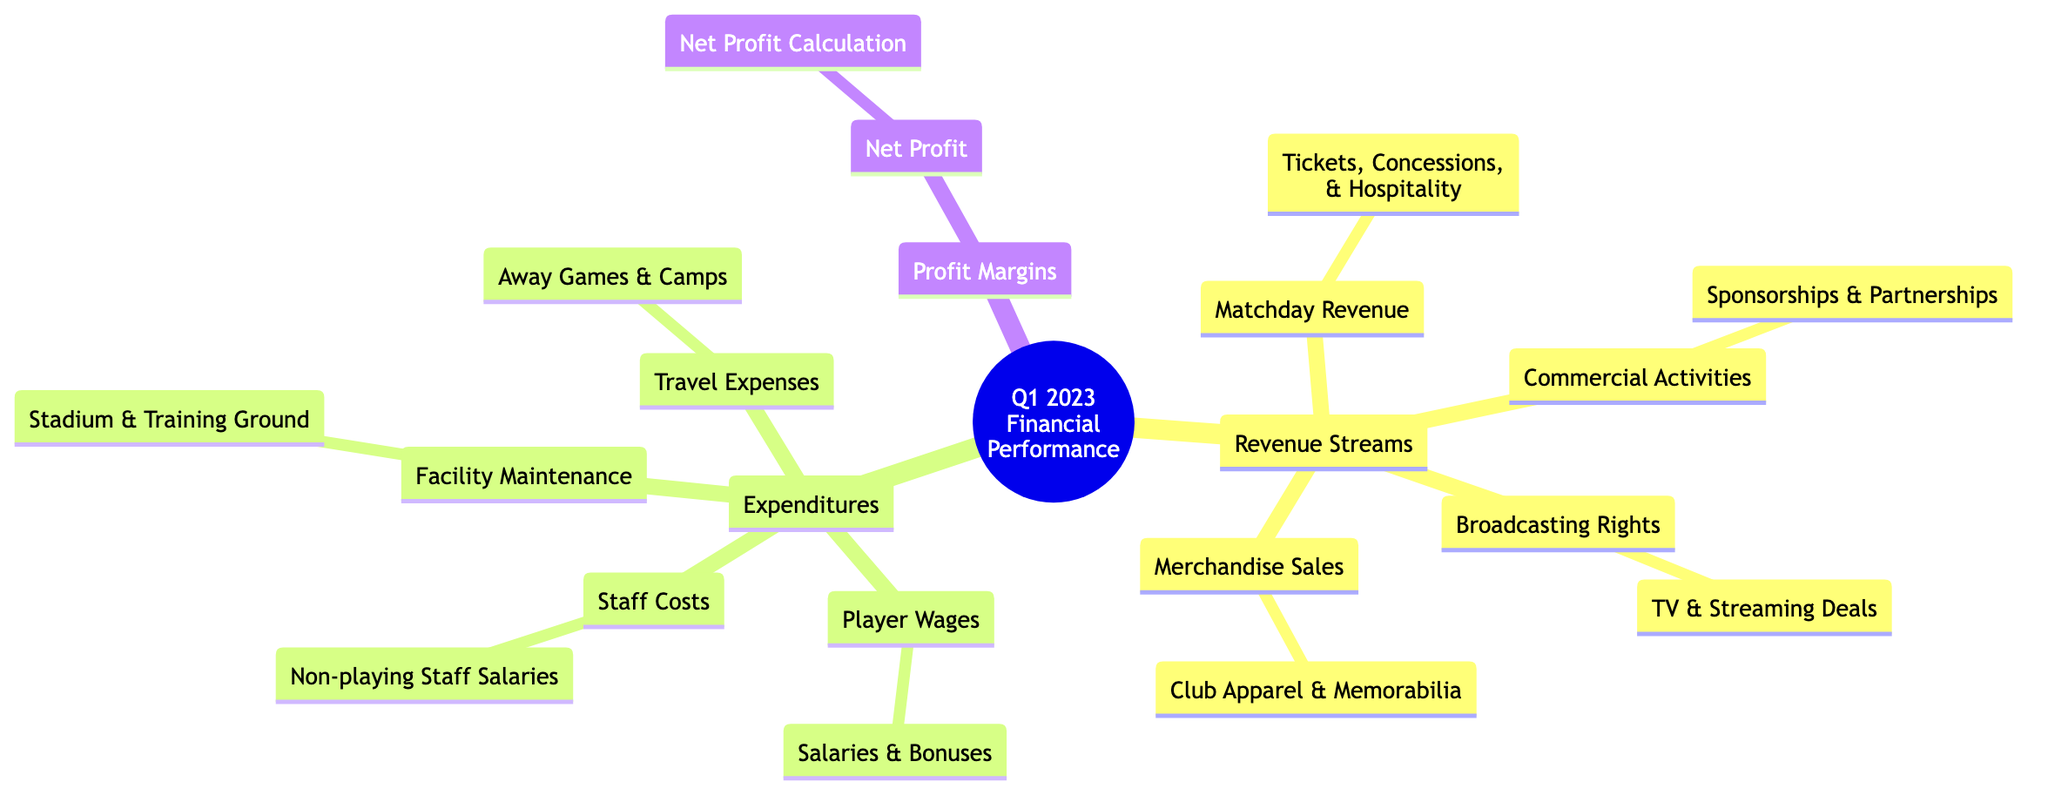What are the components of Revenue Streams? The diagram lists four components under Revenue Streams: Matchday Revenue, Broadcasting Rights, Commercial Activities, and Merchandise Sales. These are explicitly laid out under the Revenue Streams section of the diagram.
Answer: Matchday Revenue, Broadcasting Rights, Commercial Activities, Merchandise Sales Which expenditure is related to player salaries? Player Wages refer to the costs associated with salaries and bonuses paid to players, specified in the Expenditures section under Player Wages.
Answer: Player Wages How many main categories are there in Expenditures? The Expenditures section contains four main categories: Player Wages, Staff Costs, Facility Maintenance, and Travel Expenses. To find the number, we simply count the listed categories.
Answer: Four What is the relationship between Profit Margins and Net Profit? The diagram indicates that Net Profit is a type of calculation specifically related to Profit Margins, implying that Net Profit is part of the Profit Margins section.
Answer: Net Profit Which revenue stream includes sponsorships? Under the section for Revenue Streams, Sponsorships & Partnerships fall under Commercial Activities, indicating their relationship. Therefore, Commercial Activities are the revenue streams that include sponsorships.
Answer: Commercial Activities What are the non-revenue related expenditures listed? The non-revenue related expenditures include Staff Costs, Facility Maintenance, and Travel Expenses listed under Expenditures, as they do not generate revenue.
Answer: Staff Costs, Facility Maintenance, Travel Expenses Which category has the highest detail under Revenue Streams? The Matchday Revenue category contains the most detailed breakdown, specifying Tickets, Concessions, and Hospitality, which are subcomponents of Matchday Revenue.
Answer: Tickets, Concessions, Hospitality Are TV deals part of Broadcasting Rights? Yes, the diagram states that TV & Streaming Deals are part of Broadcasting Rights, making them directly related. Thus, TV deals fall under this category.
Answer: Yes 